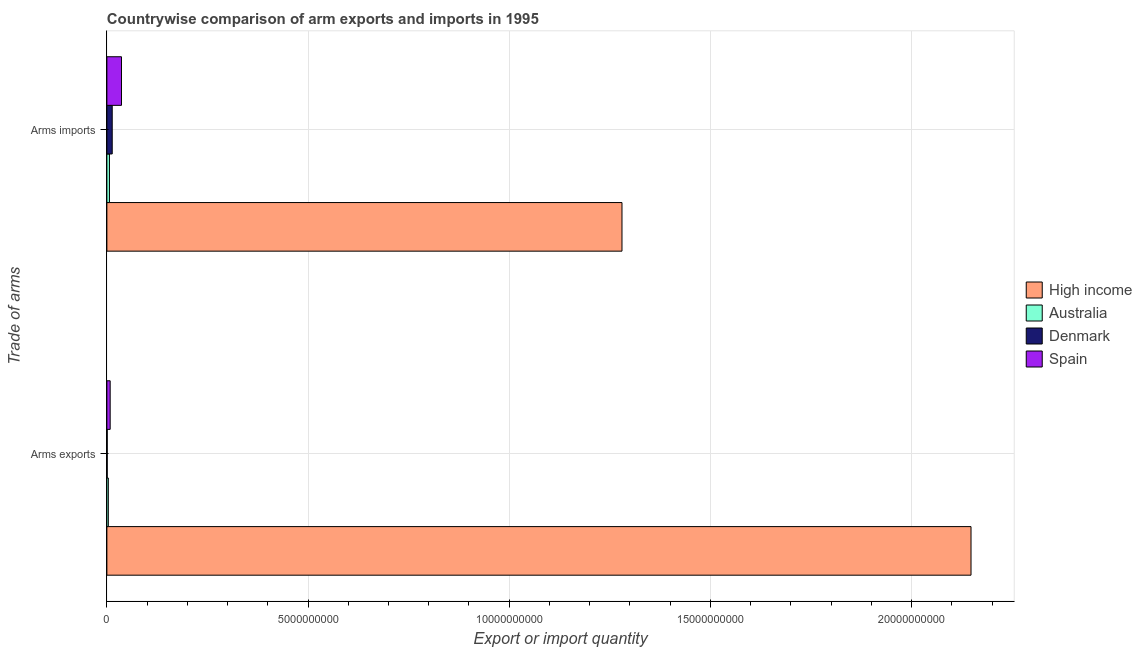How many different coloured bars are there?
Your response must be concise. 4. How many bars are there on the 2nd tick from the top?
Provide a short and direct response. 4. How many bars are there on the 1st tick from the bottom?
Provide a succinct answer. 4. What is the label of the 1st group of bars from the top?
Provide a succinct answer. Arms imports. What is the arms exports in Denmark?
Your answer should be compact. 8.00e+06. Across all countries, what is the maximum arms exports?
Provide a short and direct response. 2.15e+1. Across all countries, what is the minimum arms imports?
Ensure brevity in your answer.  6.40e+07. In which country was the arms exports maximum?
Offer a very short reply. High income. In which country was the arms exports minimum?
Make the answer very short. Denmark. What is the total arms imports in the graph?
Ensure brevity in your answer.  1.34e+1. What is the difference between the arms imports in Australia and that in Spain?
Your answer should be very brief. -2.99e+08. What is the difference between the arms imports in High income and the arms exports in Australia?
Keep it short and to the point. 1.28e+1. What is the average arms imports per country?
Make the answer very short. 3.34e+09. What is the difference between the arms exports and arms imports in Australia?
Give a very brief answer. -2.80e+07. In how many countries, is the arms imports greater than 10000000000 ?
Provide a succinct answer. 1. What is the ratio of the arms imports in Denmark to that in High income?
Offer a terse response. 0.01. In how many countries, is the arms imports greater than the average arms imports taken over all countries?
Ensure brevity in your answer.  1. What does the 4th bar from the top in Arms imports represents?
Keep it short and to the point. High income. What does the 3rd bar from the bottom in Arms imports represents?
Make the answer very short. Denmark. How many bars are there?
Provide a short and direct response. 8. Are the values on the major ticks of X-axis written in scientific E-notation?
Offer a terse response. No. Does the graph contain any zero values?
Your answer should be compact. No. Does the graph contain grids?
Provide a succinct answer. Yes. How many legend labels are there?
Offer a very short reply. 4. What is the title of the graph?
Your response must be concise. Countrywise comparison of arm exports and imports in 1995. What is the label or title of the X-axis?
Give a very brief answer. Export or import quantity. What is the label or title of the Y-axis?
Keep it short and to the point. Trade of arms. What is the Export or import quantity of High income in Arms exports?
Your answer should be compact. 2.15e+1. What is the Export or import quantity of Australia in Arms exports?
Your answer should be compact. 3.60e+07. What is the Export or import quantity in Denmark in Arms exports?
Keep it short and to the point. 8.00e+06. What is the Export or import quantity in Spain in Arms exports?
Ensure brevity in your answer.  8.20e+07. What is the Export or import quantity in High income in Arms imports?
Keep it short and to the point. 1.28e+1. What is the Export or import quantity in Australia in Arms imports?
Provide a short and direct response. 6.40e+07. What is the Export or import quantity of Denmark in Arms imports?
Provide a short and direct response. 1.33e+08. What is the Export or import quantity in Spain in Arms imports?
Your answer should be very brief. 3.63e+08. Across all Trade of arms, what is the maximum Export or import quantity of High income?
Give a very brief answer. 2.15e+1. Across all Trade of arms, what is the maximum Export or import quantity in Australia?
Offer a terse response. 6.40e+07. Across all Trade of arms, what is the maximum Export or import quantity of Denmark?
Your answer should be compact. 1.33e+08. Across all Trade of arms, what is the maximum Export or import quantity in Spain?
Ensure brevity in your answer.  3.63e+08. Across all Trade of arms, what is the minimum Export or import quantity in High income?
Provide a succinct answer. 1.28e+1. Across all Trade of arms, what is the minimum Export or import quantity in Australia?
Offer a terse response. 3.60e+07. Across all Trade of arms, what is the minimum Export or import quantity in Spain?
Provide a short and direct response. 8.20e+07. What is the total Export or import quantity in High income in the graph?
Provide a short and direct response. 3.43e+1. What is the total Export or import quantity of Denmark in the graph?
Provide a short and direct response. 1.41e+08. What is the total Export or import quantity of Spain in the graph?
Your response must be concise. 4.45e+08. What is the difference between the Export or import quantity of High income in Arms exports and that in Arms imports?
Keep it short and to the point. 8.68e+09. What is the difference between the Export or import quantity of Australia in Arms exports and that in Arms imports?
Ensure brevity in your answer.  -2.80e+07. What is the difference between the Export or import quantity of Denmark in Arms exports and that in Arms imports?
Your answer should be very brief. -1.25e+08. What is the difference between the Export or import quantity of Spain in Arms exports and that in Arms imports?
Provide a succinct answer. -2.81e+08. What is the difference between the Export or import quantity in High income in Arms exports and the Export or import quantity in Australia in Arms imports?
Provide a short and direct response. 2.14e+1. What is the difference between the Export or import quantity in High income in Arms exports and the Export or import quantity in Denmark in Arms imports?
Provide a short and direct response. 2.13e+1. What is the difference between the Export or import quantity of High income in Arms exports and the Export or import quantity of Spain in Arms imports?
Offer a very short reply. 2.11e+1. What is the difference between the Export or import quantity of Australia in Arms exports and the Export or import quantity of Denmark in Arms imports?
Offer a terse response. -9.70e+07. What is the difference between the Export or import quantity of Australia in Arms exports and the Export or import quantity of Spain in Arms imports?
Give a very brief answer. -3.27e+08. What is the difference between the Export or import quantity in Denmark in Arms exports and the Export or import quantity in Spain in Arms imports?
Make the answer very short. -3.55e+08. What is the average Export or import quantity of High income per Trade of arms?
Provide a succinct answer. 1.71e+1. What is the average Export or import quantity in Australia per Trade of arms?
Give a very brief answer. 5.00e+07. What is the average Export or import quantity in Denmark per Trade of arms?
Ensure brevity in your answer.  7.05e+07. What is the average Export or import quantity in Spain per Trade of arms?
Offer a very short reply. 2.22e+08. What is the difference between the Export or import quantity in High income and Export or import quantity in Australia in Arms exports?
Your response must be concise. 2.14e+1. What is the difference between the Export or import quantity in High income and Export or import quantity in Denmark in Arms exports?
Your answer should be very brief. 2.15e+1. What is the difference between the Export or import quantity of High income and Export or import quantity of Spain in Arms exports?
Offer a terse response. 2.14e+1. What is the difference between the Export or import quantity in Australia and Export or import quantity in Denmark in Arms exports?
Give a very brief answer. 2.80e+07. What is the difference between the Export or import quantity in Australia and Export or import quantity in Spain in Arms exports?
Provide a short and direct response. -4.60e+07. What is the difference between the Export or import quantity in Denmark and Export or import quantity in Spain in Arms exports?
Make the answer very short. -7.40e+07. What is the difference between the Export or import quantity in High income and Export or import quantity in Australia in Arms imports?
Your response must be concise. 1.27e+1. What is the difference between the Export or import quantity of High income and Export or import quantity of Denmark in Arms imports?
Provide a short and direct response. 1.27e+1. What is the difference between the Export or import quantity in High income and Export or import quantity in Spain in Arms imports?
Offer a terse response. 1.24e+1. What is the difference between the Export or import quantity of Australia and Export or import quantity of Denmark in Arms imports?
Your response must be concise. -6.90e+07. What is the difference between the Export or import quantity in Australia and Export or import quantity in Spain in Arms imports?
Your response must be concise. -2.99e+08. What is the difference between the Export or import quantity in Denmark and Export or import quantity in Spain in Arms imports?
Keep it short and to the point. -2.30e+08. What is the ratio of the Export or import quantity in High income in Arms exports to that in Arms imports?
Your answer should be very brief. 1.68. What is the ratio of the Export or import quantity of Australia in Arms exports to that in Arms imports?
Your answer should be compact. 0.56. What is the ratio of the Export or import quantity in Denmark in Arms exports to that in Arms imports?
Keep it short and to the point. 0.06. What is the ratio of the Export or import quantity of Spain in Arms exports to that in Arms imports?
Provide a succinct answer. 0.23. What is the difference between the highest and the second highest Export or import quantity in High income?
Make the answer very short. 8.68e+09. What is the difference between the highest and the second highest Export or import quantity of Australia?
Offer a very short reply. 2.80e+07. What is the difference between the highest and the second highest Export or import quantity of Denmark?
Make the answer very short. 1.25e+08. What is the difference between the highest and the second highest Export or import quantity of Spain?
Give a very brief answer. 2.81e+08. What is the difference between the highest and the lowest Export or import quantity in High income?
Keep it short and to the point. 8.68e+09. What is the difference between the highest and the lowest Export or import quantity in Australia?
Your answer should be very brief. 2.80e+07. What is the difference between the highest and the lowest Export or import quantity in Denmark?
Offer a terse response. 1.25e+08. What is the difference between the highest and the lowest Export or import quantity in Spain?
Your answer should be compact. 2.81e+08. 